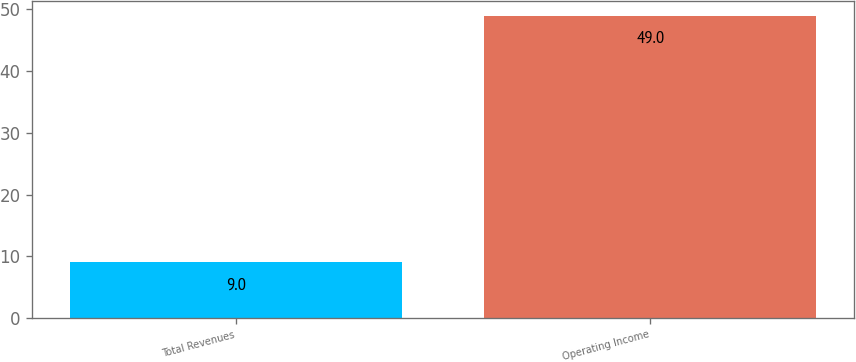<chart> <loc_0><loc_0><loc_500><loc_500><bar_chart><fcel>Total Revenues<fcel>Operating Income<nl><fcel>9<fcel>49<nl></chart> 